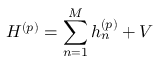Convert formula to latex. <formula><loc_0><loc_0><loc_500><loc_500>H ^ { ( p ) } = \sum _ { n = 1 } ^ { M } h _ { n } ^ { ( p ) } + V</formula> 